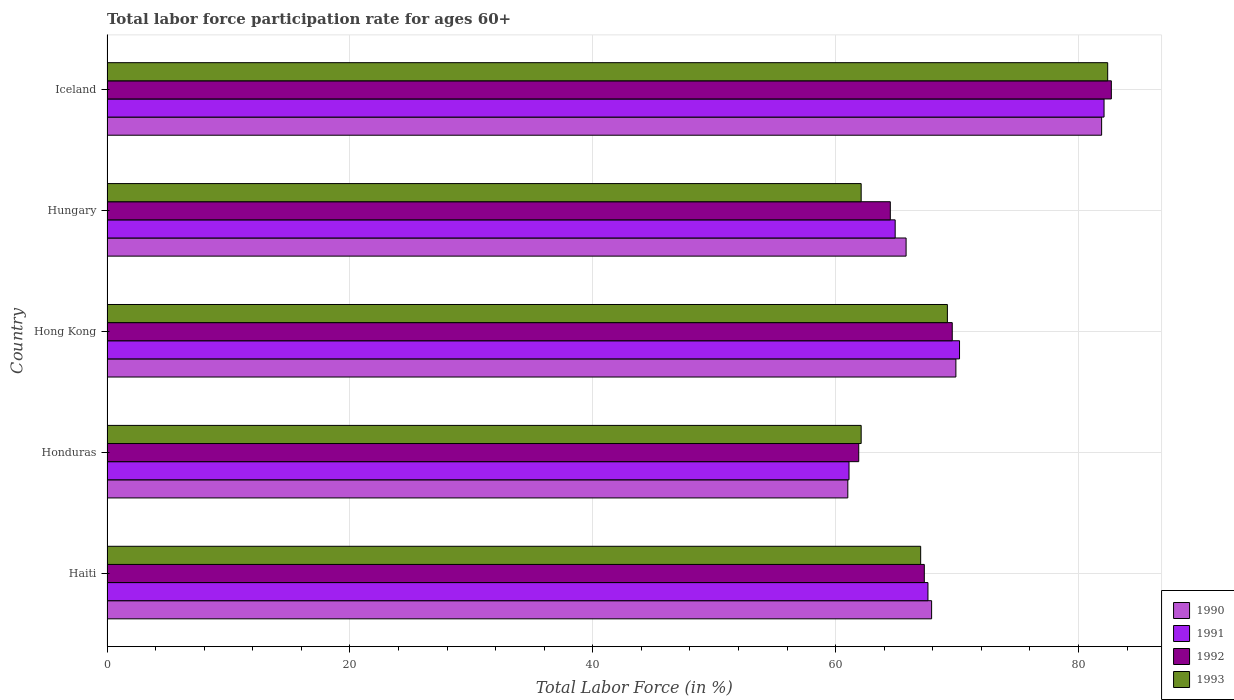How many different coloured bars are there?
Give a very brief answer. 4. How many groups of bars are there?
Give a very brief answer. 5. Are the number of bars per tick equal to the number of legend labels?
Your answer should be compact. Yes. Are the number of bars on each tick of the Y-axis equal?
Your answer should be compact. Yes. How many bars are there on the 4th tick from the bottom?
Your answer should be compact. 4. In how many cases, is the number of bars for a given country not equal to the number of legend labels?
Keep it short and to the point. 0. What is the labor force participation rate in 1992 in Honduras?
Provide a succinct answer. 61.9. Across all countries, what is the maximum labor force participation rate in 1993?
Give a very brief answer. 82.4. Across all countries, what is the minimum labor force participation rate in 1992?
Make the answer very short. 61.9. In which country was the labor force participation rate in 1992 minimum?
Your answer should be compact. Honduras. What is the total labor force participation rate in 1993 in the graph?
Keep it short and to the point. 342.8. What is the difference between the labor force participation rate in 1991 in Haiti and that in Iceland?
Ensure brevity in your answer.  -14.5. What is the average labor force participation rate in 1992 per country?
Keep it short and to the point. 69.2. What is the difference between the labor force participation rate in 1993 and labor force participation rate in 1990 in Haiti?
Offer a very short reply. -0.9. What is the ratio of the labor force participation rate in 1991 in Honduras to that in Hungary?
Keep it short and to the point. 0.94. Is the difference between the labor force participation rate in 1993 in Hong Kong and Hungary greater than the difference between the labor force participation rate in 1990 in Hong Kong and Hungary?
Your response must be concise. Yes. What is the difference between the highest and the second highest labor force participation rate in 1992?
Offer a very short reply. 13.1. What is the difference between the highest and the lowest labor force participation rate in 1992?
Provide a short and direct response. 20.8. Is it the case that in every country, the sum of the labor force participation rate in 1990 and labor force participation rate in 1992 is greater than the sum of labor force participation rate in 1991 and labor force participation rate in 1993?
Your answer should be very brief. No. Is it the case that in every country, the sum of the labor force participation rate in 1990 and labor force participation rate in 1992 is greater than the labor force participation rate in 1991?
Ensure brevity in your answer.  Yes. How many bars are there?
Offer a very short reply. 20. Does the graph contain any zero values?
Make the answer very short. No. Does the graph contain grids?
Offer a very short reply. Yes. How many legend labels are there?
Offer a very short reply. 4. How are the legend labels stacked?
Ensure brevity in your answer.  Vertical. What is the title of the graph?
Offer a very short reply. Total labor force participation rate for ages 60+. What is the label or title of the X-axis?
Keep it short and to the point. Total Labor Force (in %). What is the label or title of the Y-axis?
Offer a very short reply. Country. What is the Total Labor Force (in %) in 1990 in Haiti?
Your response must be concise. 67.9. What is the Total Labor Force (in %) in 1991 in Haiti?
Provide a short and direct response. 67.6. What is the Total Labor Force (in %) in 1992 in Haiti?
Your response must be concise. 67.3. What is the Total Labor Force (in %) of 1990 in Honduras?
Your answer should be very brief. 61. What is the Total Labor Force (in %) of 1991 in Honduras?
Your answer should be very brief. 61.1. What is the Total Labor Force (in %) of 1992 in Honduras?
Your answer should be compact. 61.9. What is the Total Labor Force (in %) in 1993 in Honduras?
Keep it short and to the point. 62.1. What is the Total Labor Force (in %) of 1990 in Hong Kong?
Provide a succinct answer. 69.9. What is the Total Labor Force (in %) of 1991 in Hong Kong?
Offer a very short reply. 70.2. What is the Total Labor Force (in %) of 1992 in Hong Kong?
Offer a very short reply. 69.6. What is the Total Labor Force (in %) in 1993 in Hong Kong?
Provide a succinct answer. 69.2. What is the Total Labor Force (in %) of 1990 in Hungary?
Offer a very short reply. 65.8. What is the Total Labor Force (in %) of 1991 in Hungary?
Offer a terse response. 64.9. What is the Total Labor Force (in %) of 1992 in Hungary?
Offer a very short reply. 64.5. What is the Total Labor Force (in %) of 1993 in Hungary?
Your answer should be compact. 62.1. What is the Total Labor Force (in %) of 1990 in Iceland?
Offer a terse response. 81.9. What is the Total Labor Force (in %) in 1991 in Iceland?
Provide a short and direct response. 82.1. What is the Total Labor Force (in %) in 1992 in Iceland?
Your response must be concise. 82.7. What is the Total Labor Force (in %) in 1993 in Iceland?
Keep it short and to the point. 82.4. Across all countries, what is the maximum Total Labor Force (in %) in 1990?
Your answer should be very brief. 81.9. Across all countries, what is the maximum Total Labor Force (in %) of 1991?
Your answer should be very brief. 82.1. Across all countries, what is the maximum Total Labor Force (in %) of 1992?
Your answer should be compact. 82.7. Across all countries, what is the maximum Total Labor Force (in %) in 1993?
Offer a very short reply. 82.4. Across all countries, what is the minimum Total Labor Force (in %) of 1990?
Offer a very short reply. 61. Across all countries, what is the minimum Total Labor Force (in %) in 1991?
Provide a short and direct response. 61.1. Across all countries, what is the minimum Total Labor Force (in %) in 1992?
Make the answer very short. 61.9. Across all countries, what is the minimum Total Labor Force (in %) in 1993?
Provide a succinct answer. 62.1. What is the total Total Labor Force (in %) of 1990 in the graph?
Make the answer very short. 346.5. What is the total Total Labor Force (in %) in 1991 in the graph?
Ensure brevity in your answer.  345.9. What is the total Total Labor Force (in %) in 1992 in the graph?
Your response must be concise. 346. What is the total Total Labor Force (in %) of 1993 in the graph?
Keep it short and to the point. 342.8. What is the difference between the Total Labor Force (in %) in 1990 in Haiti and that in Honduras?
Offer a terse response. 6.9. What is the difference between the Total Labor Force (in %) of 1992 in Haiti and that in Honduras?
Provide a short and direct response. 5.4. What is the difference between the Total Labor Force (in %) in 1993 in Haiti and that in Honduras?
Make the answer very short. 4.9. What is the difference between the Total Labor Force (in %) in 1991 in Haiti and that in Hong Kong?
Keep it short and to the point. -2.6. What is the difference between the Total Labor Force (in %) of 1992 in Haiti and that in Hong Kong?
Your answer should be compact. -2.3. What is the difference between the Total Labor Force (in %) of 1993 in Haiti and that in Hong Kong?
Offer a terse response. -2.2. What is the difference between the Total Labor Force (in %) of 1991 in Haiti and that in Hungary?
Keep it short and to the point. 2.7. What is the difference between the Total Labor Force (in %) of 1990 in Haiti and that in Iceland?
Give a very brief answer. -14. What is the difference between the Total Labor Force (in %) in 1992 in Haiti and that in Iceland?
Ensure brevity in your answer.  -15.4. What is the difference between the Total Labor Force (in %) in 1993 in Haiti and that in Iceland?
Offer a very short reply. -15.4. What is the difference between the Total Labor Force (in %) in 1992 in Honduras and that in Hong Kong?
Your answer should be very brief. -7.7. What is the difference between the Total Labor Force (in %) of 1993 in Honduras and that in Hong Kong?
Provide a succinct answer. -7.1. What is the difference between the Total Labor Force (in %) in 1992 in Honduras and that in Hungary?
Offer a terse response. -2.6. What is the difference between the Total Labor Force (in %) of 1990 in Honduras and that in Iceland?
Make the answer very short. -20.9. What is the difference between the Total Labor Force (in %) of 1992 in Honduras and that in Iceland?
Your answer should be very brief. -20.8. What is the difference between the Total Labor Force (in %) in 1993 in Honduras and that in Iceland?
Your answer should be compact. -20.3. What is the difference between the Total Labor Force (in %) in 1991 in Hong Kong and that in Hungary?
Your answer should be very brief. 5.3. What is the difference between the Total Labor Force (in %) in 1990 in Hong Kong and that in Iceland?
Offer a very short reply. -12. What is the difference between the Total Labor Force (in %) in 1993 in Hong Kong and that in Iceland?
Ensure brevity in your answer.  -13.2. What is the difference between the Total Labor Force (in %) of 1990 in Hungary and that in Iceland?
Your answer should be compact. -16.1. What is the difference between the Total Labor Force (in %) of 1991 in Hungary and that in Iceland?
Provide a succinct answer. -17.2. What is the difference between the Total Labor Force (in %) in 1992 in Hungary and that in Iceland?
Your answer should be compact. -18.2. What is the difference between the Total Labor Force (in %) in 1993 in Hungary and that in Iceland?
Provide a short and direct response. -20.3. What is the difference between the Total Labor Force (in %) in 1990 in Haiti and the Total Labor Force (in %) in 1991 in Honduras?
Your answer should be compact. 6.8. What is the difference between the Total Labor Force (in %) in 1990 in Haiti and the Total Labor Force (in %) in 1992 in Honduras?
Offer a very short reply. 6. What is the difference between the Total Labor Force (in %) of 1991 in Haiti and the Total Labor Force (in %) of 1993 in Honduras?
Offer a very short reply. 5.5. What is the difference between the Total Labor Force (in %) in 1992 in Haiti and the Total Labor Force (in %) in 1993 in Honduras?
Provide a short and direct response. 5.2. What is the difference between the Total Labor Force (in %) of 1990 in Haiti and the Total Labor Force (in %) of 1991 in Hong Kong?
Make the answer very short. -2.3. What is the difference between the Total Labor Force (in %) in 1990 in Haiti and the Total Labor Force (in %) in 1993 in Hong Kong?
Ensure brevity in your answer.  -1.3. What is the difference between the Total Labor Force (in %) of 1991 in Haiti and the Total Labor Force (in %) of 1993 in Hong Kong?
Give a very brief answer. -1.6. What is the difference between the Total Labor Force (in %) of 1992 in Haiti and the Total Labor Force (in %) of 1993 in Hong Kong?
Your answer should be very brief. -1.9. What is the difference between the Total Labor Force (in %) in 1990 in Haiti and the Total Labor Force (in %) in 1992 in Hungary?
Offer a very short reply. 3.4. What is the difference between the Total Labor Force (in %) in 1991 in Haiti and the Total Labor Force (in %) in 1993 in Hungary?
Offer a very short reply. 5.5. What is the difference between the Total Labor Force (in %) of 1990 in Haiti and the Total Labor Force (in %) of 1991 in Iceland?
Offer a very short reply. -14.2. What is the difference between the Total Labor Force (in %) of 1990 in Haiti and the Total Labor Force (in %) of 1992 in Iceland?
Provide a short and direct response. -14.8. What is the difference between the Total Labor Force (in %) of 1991 in Haiti and the Total Labor Force (in %) of 1992 in Iceland?
Make the answer very short. -15.1. What is the difference between the Total Labor Force (in %) of 1991 in Haiti and the Total Labor Force (in %) of 1993 in Iceland?
Your answer should be compact. -14.8. What is the difference between the Total Labor Force (in %) in 1992 in Haiti and the Total Labor Force (in %) in 1993 in Iceland?
Give a very brief answer. -15.1. What is the difference between the Total Labor Force (in %) of 1990 in Honduras and the Total Labor Force (in %) of 1993 in Hong Kong?
Provide a succinct answer. -8.2. What is the difference between the Total Labor Force (in %) in 1991 in Honduras and the Total Labor Force (in %) in 1993 in Hong Kong?
Give a very brief answer. -8.1. What is the difference between the Total Labor Force (in %) of 1992 in Honduras and the Total Labor Force (in %) of 1993 in Hong Kong?
Provide a succinct answer. -7.3. What is the difference between the Total Labor Force (in %) of 1990 in Honduras and the Total Labor Force (in %) of 1992 in Hungary?
Your answer should be very brief. -3.5. What is the difference between the Total Labor Force (in %) of 1990 in Honduras and the Total Labor Force (in %) of 1991 in Iceland?
Provide a short and direct response. -21.1. What is the difference between the Total Labor Force (in %) of 1990 in Honduras and the Total Labor Force (in %) of 1992 in Iceland?
Keep it short and to the point. -21.7. What is the difference between the Total Labor Force (in %) of 1990 in Honduras and the Total Labor Force (in %) of 1993 in Iceland?
Ensure brevity in your answer.  -21.4. What is the difference between the Total Labor Force (in %) in 1991 in Honduras and the Total Labor Force (in %) in 1992 in Iceland?
Offer a terse response. -21.6. What is the difference between the Total Labor Force (in %) of 1991 in Honduras and the Total Labor Force (in %) of 1993 in Iceland?
Provide a succinct answer. -21.3. What is the difference between the Total Labor Force (in %) of 1992 in Honduras and the Total Labor Force (in %) of 1993 in Iceland?
Offer a terse response. -20.5. What is the difference between the Total Labor Force (in %) in 1990 in Hong Kong and the Total Labor Force (in %) in 1991 in Hungary?
Provide a short and direct response. 5. What is the difference between the Total Labor Force (in %) of 1990 in Hong Kong and the Total Labor Force (in %) of 1993 in Hungary?
Keep it short and to the point. 7.8. What is the difference between the Total Labor Force (in %) in 1991 in Hong Kong and the Total Labor Force (in %) in 1992 in Hungary?
Your answer should be very brief. 5.7. What is the difference between the Total Labor Force (in %) in 1992 in Hong Kong and the Total Labor Force (in %) in 1993 in Hungary?
Offer a very short reply. 7.5. What is the difference between the Total Labor Force (in %) in 1990 in Hong Kong and the Total Labor Force (in %) in 1991 in Iceland?
Ensure brevity in your answer.  -12.2. What is the difference between the Total Labor Force (in %) of 1991 in Hong Kong and the Total Labor Force (in %) of 1993 in Iceland?
Provide a succinct answer. -12.2. What is the difference between the Total Labor Force (in %) of 1990 in Hungary and the Total Labor Force (in %) of 1991 in Iceland?
Your answer should be very brief. -16.3. What is the difference between the Total Labor Force (in %) of 1990 in Hungary and the Total Labor Force (in %) of 1992 in Iceland?
Your answer should be compact. -16.9. What is the difference between the Total Labor Force (in %) of 1990 in Hungary and the Total Labor Force (in %) of 1993 in Iceland?
Offer a terse response. -16.6. What is the difference between the Total Labor Force (in %) of 1991 in Hungary and the Total Labor Force (in %) of 1992 in Iceland?
Make the answer very short. -17.8. What is the difference between the Total Labor Force (in %) of 1991 in Hungary and the Total Labor Force (in %) of 1993 in Iceland?
Provide a succinct answer. -17.5. What is the difference between the Total Labor Force (in %) in 1992 in Hungary and the Total Labor Force (in %) in 1993 in Iceland?
Keep it short and to the point. -17.9. What is the average Total Labor Force (in %) of 1990 per country?
Give a very brief answer. 69.3. What is the average Total Labor Force (in %) of 1991 per country?
Your response must be concise. 69.18. What is the average Total Labor Force (in %) in 1992 per country?
Your response must be concise. 69.2. What is the average Total Labor Force (in %) in 1993 per country?
Ensure brevity in your answer.  68.56. What is the difference between the Total Labor Force (in %) in 1990 and Total Labor Force (in %) in 1991 in Haiti?
Your answer should be very brief. 0.3. What is the difference between the Total Labor Force (in %) of 1990 and Total Labor Force (in %) of 1993 in Haiti?
Offer a terse response. 0.9. What is the difference between the Total Labor Force (in %) of 1991 and Total Labor Force (in %) of 1992 in Haiti?
Provide a succinct answer. 0.3. What is the difference between the Total Labor Force (in %) in 1991 and Total Labor Force (in %) in 1993 in Haiti?
Your response must be concise. 0.6. What is the difference between the Total Labor Force (in %) of 1991 and Total Labor Force (in %) of 1993 in Honduras?
Offer a very short reply. -1. What is the difference between the Total Labor Force (in %) of 1990 and Total Labor Force (in %) of 1991 in Hong Kong?
Ensure brevity in your answer.  -0.3. What is the difference between the Total Labor Force (in %) of 1990 and Total Labor Force (in %) of 1992 in Hong Kong?
Give a very brief answer. 0.3. What is the difference between the Total Labor Force (in %) of 1991 and Total Labor Force (in %) of 1992 in Hong Kong?
Keep it short and to the point. 0.6. What is the difference between the Total Labor Force (in %) of 1991 and Total Labor Force (in %) of 1993 in Hong Kong?
Make the answer very short. 1. What is the difference between the Total Labor Force (in %) of 1990 and Total Labor Force (in %) of 1991 in Hungary?
Ensure brevity in your answer.  0.9. What is the difference between the Total Labor Force (in %) in 1990 and Total Labor Force (in %) in 1992 in Hungary?
Offer a very short reply. 1.3. What is the difference between the Total Labor Force (in %) in 1990 and Total Labor Force (in %) in 1993 in Hungary?
Give a very brief answer. 3.7. What is the difference between the Total Labor Force (in %) of 1991 and Total Labor Force (in %) of 1993 in Hungary?
Your answer should be very brief. 2.8. What is the difference between the Total Labor Force (in %) in 1992 and Total Labor Force (in %) in 1993 in Hungary?
Provide a short and direct response. 2.4. What is the difference between the Total Labor Force (in %) of 1990 and Total Labor Force (in %) of 1991 in Iceland?
Offer a very short reply. -0.2. What is the difference between the Total Labor Force (in %) of 1990 and Total Labor Force (in %) of 1993 in Iceland?
Your answer should be very brief. -0.5. What is the difference between the Total Labor Force (in %) of 1991 and Total Labor Force (in %) of 1993 in Iceland?
Keep it short and to the point. -0.3. What is the difference between the Total Labor Force (in %) of 1992 and Total Labor Force (in %) of 1993 in Iceland?
Offer a very short reply. 0.3. What is the ratio of the Total Labor Force (in %) in 1990 in Haiti to that in Honduras?
Make the answer very short. 1.11. What is the ratio of the Total Labor Force (in %) of 1991 in Haiti to that in Honduras?
Keep it short and to the point. 1.11. What is the ratio of the Total Labor Force (in %) of 1992 in Haiti to that in Honduras?
Make the answer very short. 1.09. What is the ratio of the Total Labor Force (in %) in 1993 in Haiti to that in Honduras?
Ensure brevity in your answer.  1.08. What is the ratio of the Total Labor Force (in %) of 1990 in Haiti to that in Hong Kong?
Make the answer very short. 0.97. What is the ratio of the Total Labor Force (in %) in 1993 in Haiti to that in Hong Kong?
Offer a very short reply. 0.97. What is the ratio of the Total Labor Force (in %) in 1990 in Haiti to that in Hungary?
Offer a terse response. 1.03. What is the ratio of the Total Labor Force (in %) of 1991 in Haiti to that in Hungary?
Provide a succinct answer. 1.04. What is the ratio of the Total Labor Force (in %) in 1992 in Haiti to that in Hungary?
Give a very brief answer. 1.04. What is the ratio of the Total Labor Force (in %) of 1993 in Haiti to that in Hungary?
Provide a short and direct response. 1.08. What is the ratio of the Total Labor Force (in %) of 1990 in Haiti to that in Iceland?
Your response must be concise. 0.83. What is the ratio of the Total Labor Force (in %) in 1991 in Haiti to that in Iceland?
Make the answer very short. 0.82. What is the ratio of the Total Labor Force (in %) in 1992 in Haiti to that in Iceland?
Keep it short and to the point. 0.81. What is the ratio of the Total Labor Force (in %) of 1993 in Haiti to that in Iceland?
Your answer should be compact. 0.81. What is the ratio of the Total Labor Force (in %) of 1990 in Honduras to that in Hong Kong?
Ensure brevity in your answer.  0.87. What is the ratio of the Total Labor Force (in %) of 1991 in Honduras to that in Hong Kong?
Your answer should be very brief. 0.87. What is the ratio of the Total Labor Force (in %) in 1992 in Honduras to that in Hong Kong?
Offer a very short reply. 0.89. What is the ratio of the Total Labor Force (in %) of 1993 in Honduras to that in Hong Kong?
Ensure brevity in your answer.  0.9. What is the ratio of the Total Labor Force (in %) of 1990 in Honduras to that in Hungary?
Your answer should be compact. 0.93. What is the ratio of the Total Labor Force (in %) in 1991 in Honduras to that in Hungary?
Your answer should be very brief. 0.94. What is the ratio of the Total Labor Force (in %) of 1992 in Honduras to that in Hungary?
Your response must be concise. 0.96. What is the ratio of the Total Labor Force (in %) of 1990 in Honduras to that in Iceland?
Your answer should be compact. 0.74. What is the ratio of the Total Labor Force (in %) of 1991 in Honduras to that in Iceland?
Your answer should be compact. 0.74. What is the ratio of the Total Labor Force (in %) in 1992 in Honduras to that in Iceland?
Your answer should be very brief. 0.75. What is the ratio of the Total Labor Force (in %) in 1993 in Honduras to that in Iceland?
Offer a very short reply. 0.75. What is the ratio of the Total Labor Force (in %) in 1990 in Hong Kong to that in Hungary?
Offer a very short reply. 1.06. What is the ratio of the Total Labor Force (in %) in 1991 in Hong Kong to that in Hungary?
Ensure brevity in your answer.  1.08. What is the ratio of the Total Labor Force (in %) in 1992 in Hong Kong to that in Hungary?
Your response must be concise. 1.08. What is the ratio of the Total Labor Force (in %) in 1993 in Hong Kong to that in Hungary?
Give a very brief answer. 1.11. What is the ratio of the Total Labor Force (in %) in 1990 in Hong Kong to that in Iceland?
Ensure brevity in your answer.  0.85. What is the ratio of the Total Labor Force (in %) of 1991 in Hong Kong to that in Iceland?
Ensure brevity in your answer.  0.86. What is the ratio of the Total Labor Force (in %) of 1992 in Hong Kong to that in Iceland?
Your answer should be compact. 0.84. What is the ratio of the Total Labor Force (in %) of 1993 in Hong Kong to that in Iceland?
Make the answer very short. 0.84. What is the ratio of the Total Labor Force (in %) of 1990 in Hungary to that in Iceland?
Your answer should be compact. 0.8. What is the ratio of the Total Labor Force (in %) in 1991 in Hungary to that in Iceland?
Provide a short and direct response. 0.79. What is the ratio of the Total Labor Force (in %) of 1992 in Hungary to that in Iceland?
Your answer should be very brief. 0.78. What is the ratio of the Total Labor Force (in %) in 1993 in Hungary to that in Iceland?
Give a very brief answer. 0.75. What is the difference between the highest and the second highest Total Labor Force (in %) of 1991?
Your answer should be compact. 11.9. What is the difference between the highest and the lowest Total Labor Force (in %) of 1990?
Offer a terse response. 20.9. What is the difference between the highest and the lowest Total Labor Force (in %) of 1991?
Provide a succinct answer. 21. What is the difference between the highest and the lowest Total Labor Force (in %) of 1992?
Offer a terse response. 20.8. What is the difference between the highest and the lowest Total Labor Force (in %) in 1993?
Make the answer very short. 20.3. 